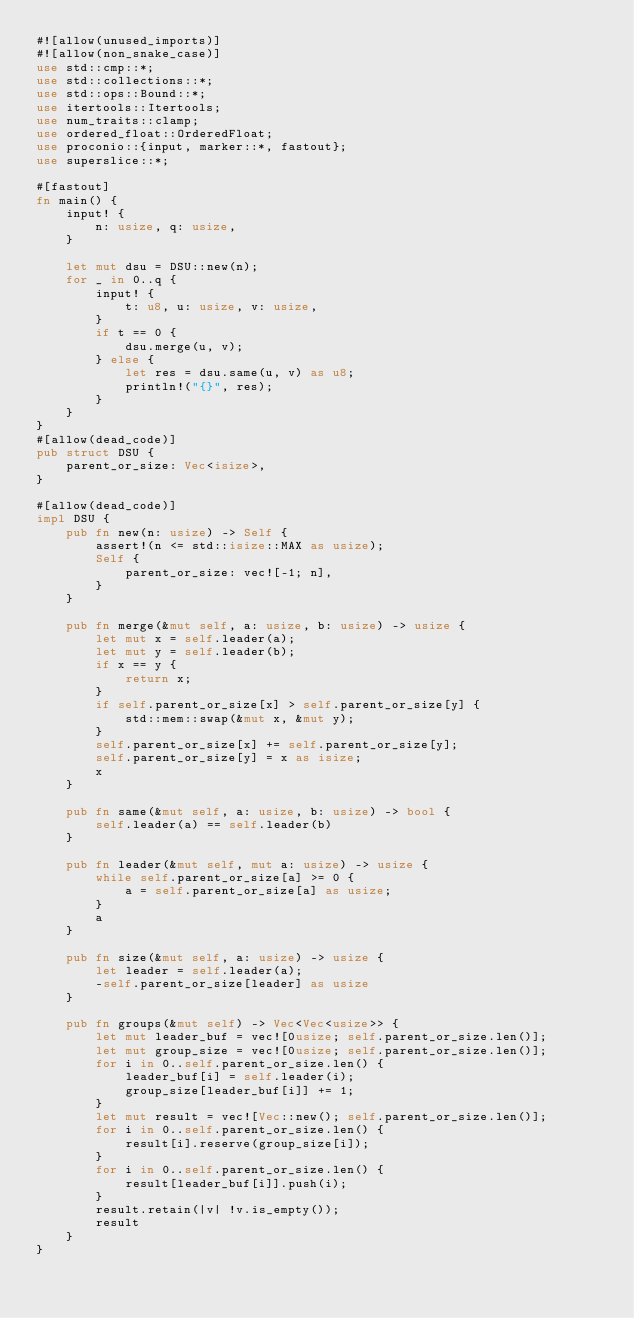<code> <loc_0><loc_0><loc_500><loc_500><_Rust_>#![allow(unused_imports)]
#![allow(non_snake_case)]
use std::cmp::*;
use std::collections::*;
use std::ops::Bound::*;
use itertools::Itertools;
use num_traits::clamp;
use ordered_float::OrderedFloat;
use proconio::{input, marker::*, fastout};
use superslice::*;

#[fastout]
fn main() {
    input! {
        n: usize, q: usize,
    }

    let mut dsu = DSU::new(n);
    for _ in 0..q {
        input! {
            t: u8, u: usize, v: usize,
        }
        if t == 0 {
            dsu.merge(u, v);
        } else {
            let res = dsu.same(u, v) as u8;
            println!("{}", res);
        }
    }
}
#[allow(dead_code)]
pub struct DSU {
    parent_or_size: Vec<isize>,
}

#[allow(dead_code)]
impl DSU {
    pub fn new(n: usize) -> Self {
        assert!(n <= std::isize::MAX as usize);
        Self {
            parent_or_size: vec![-1; n],
        }
    }

    pub fn merge(&mut self, a: usize, b: usize) -> usize {
        let mut x = self.leader(a);
        let mut y = self.leader(b);
        if x == y {
            return x;
        }
        if self.parent_or_size[x] > self.parent_or_size[y] {
            std::mem::swap(&mut x, &mut y);
        }
        self.parent_or_size[x] += self.parent_or_size[y];
        self.parent_or_size[y] = x as isize;
        x
    }

    pub fn same(&mut self, a: usize, b: usize) -> bool {
        self.leader(a) == self.leader(b)
    }

    pub fn leader(&mut self, mut a: usize) -> usize {
        while self.parent_or_size[a] >= 0 {
            a = self.parent_or_size[a] as usize;
        }
        a
    }

    pub fn size(&mut self, a: usize) -> usize {
        let leader = self.leader(a);
        -self.parent_or_size[leader] as usize
    }

    pub fn groups(&mut self) -> Vec<Vec<usize>> {
        let mut leader_buf = vec![0usize; self.parent_or_size.len()];
        let mut group_size = vec![0usize; self.parent_or_size.len()];
        for i in 0..self.parent_or_size.len() {
            leader_buf[i] = self.leader(i);
            group_size[leader_buf[i]] += 1;
        }
        let mut result = vec![Vec::new(); self.parent_or_size.len()];
        for i in 0..self.parent_or_size.len() {
            result[i].reserve(group_size[i]);
        }
        for i in 0..self.parent_or_size.len() {
            result[leader_buf[i]].push(i);
        }
        result.retain(|v| !v.is_empty());
        result
    }
}</code> 